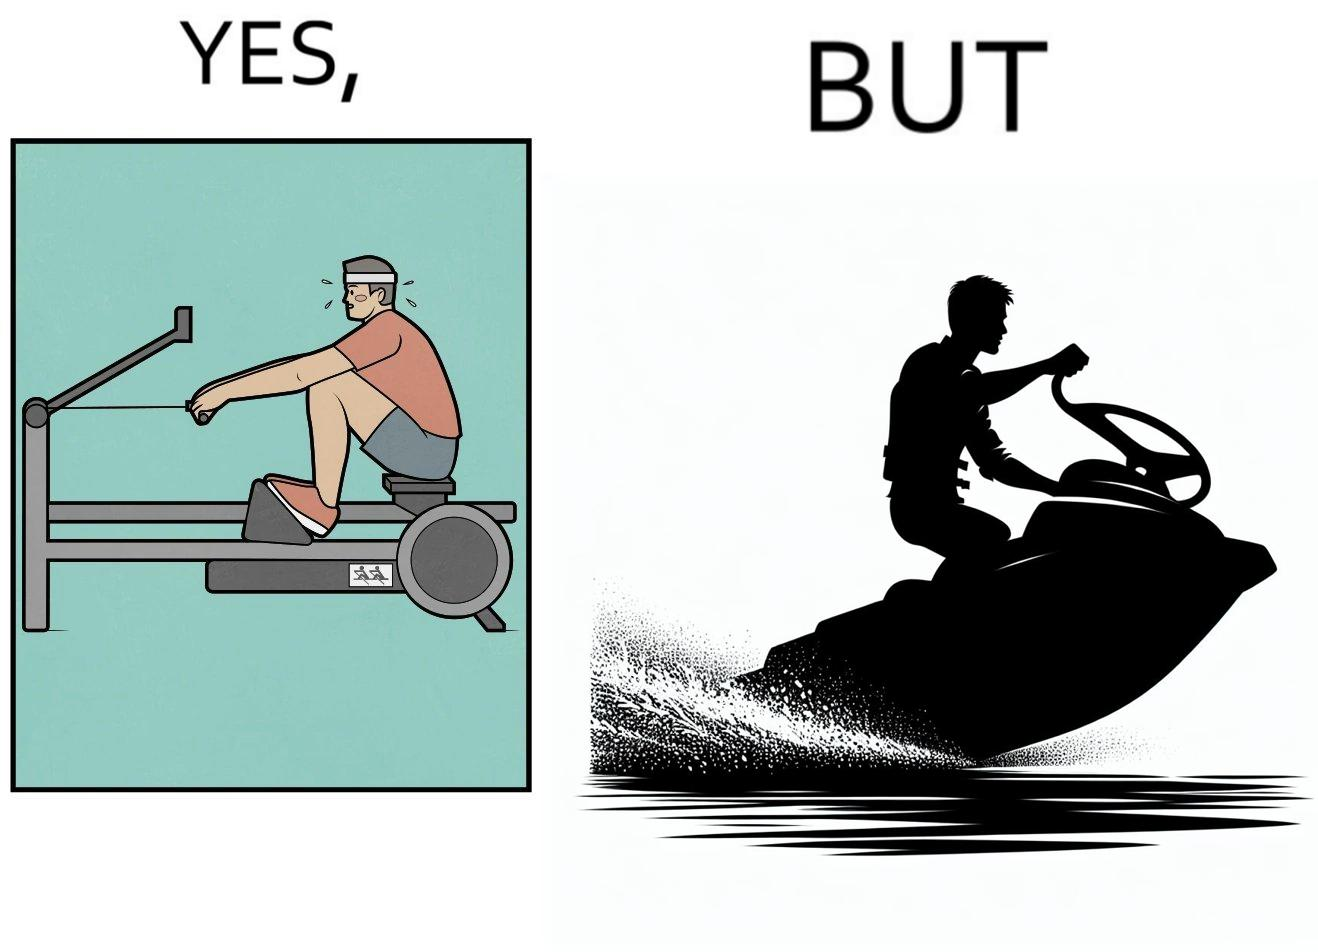What does this image depict? The image is ironic, because people often use rowing machine at the gym don't prefer rowing when it comes to boats 